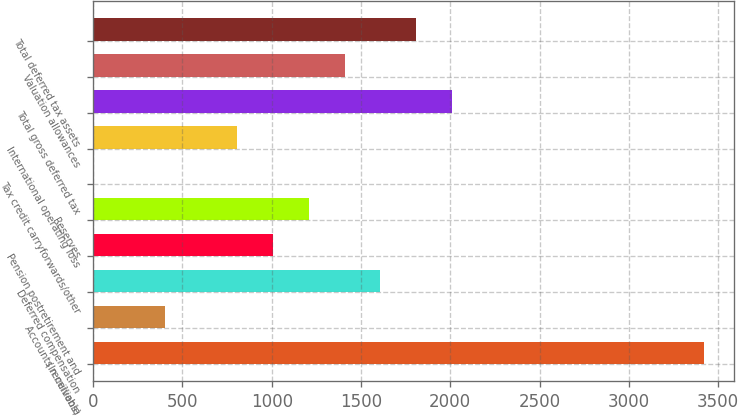Convert chart. <chart><loc_0><loc_0><loc_500><loc_500><bar_chart><fcel>(In millions)<fcel>Accounts receivable<fcel>Deferred compensation<fcel>Pension postretirement and<fcel>Reserves<fcel>Tax credit carryforwards/other<fcel>International operating loss<fcel>Total gross deferred tax<fcel>Valuation allowances<fcel>Total deferred tax assets<nl><fcel>3418.49<fcel>402.44<fcel>1608.86<fcel>1005.65<fcel>1206.72<fcel>0.3<fcel>804.58<fcel>2011<fcel>1407.79<fcel>1809.93<nl></chart> 